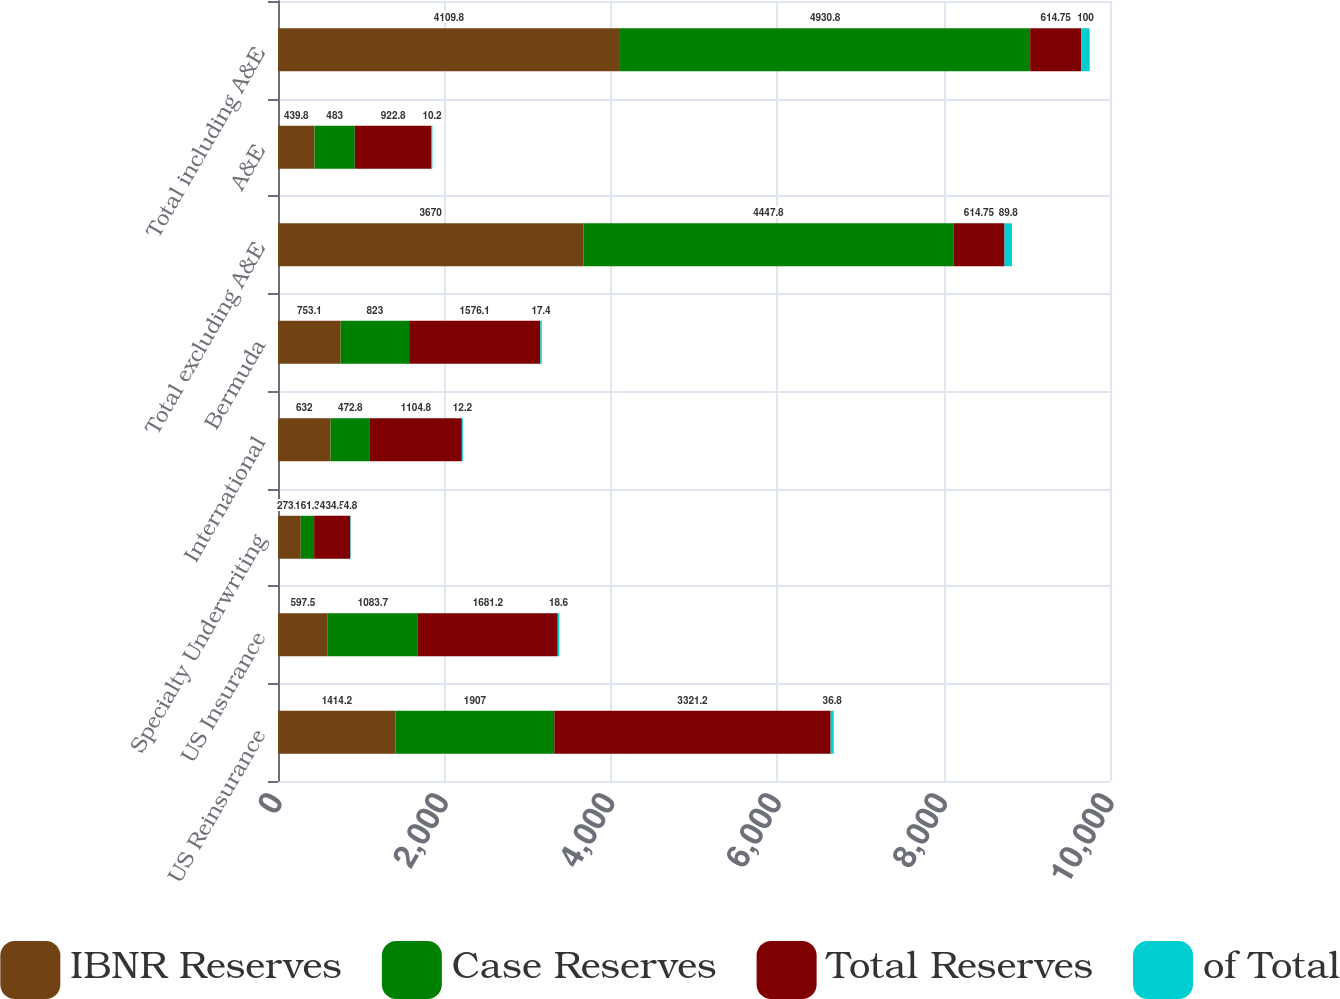Convert chart to OTSL. <chart><loc_0><loc_0><loc_500><loc_500><stacked_bar_chart><ecel><fcel>US Reinsurance<fcel>US Insurance<fcel>Specialty Underwriting<fcel>International<fcel>Bermuda<fcel>Total excluding A&E<fcel>A&E<fcel>Total including A&E<nl><fcel>IBNR Reserves<fcel>1414.2<fcel>597.5<fcel>273.2<fcel>632<fcel>753.1<fcel>3670<fcel>439.8<fcel>4109.8<nl><fcel>Case Reserves<fcel>1907<fcel>1083.7<fcel>161.3<fcel>472.8<fcel>823<fcel>4447.8<fcel>483<fcel>4930.8<nl><fcel>Total Reserves<fcel>3321.2<fcel>1681.2<fcel>434.5<fcel>1104.8<fcel>1576.1<fcel>614.75<fcel>922.8<fcel>614.75<nl><fcel>of Total<fcel>36.8<fcel>18.6<fcel>4.8<fcel>12.2<fcel>17.4<fcel>89.8<fcel>10.2<fcel>100<nl></chart> 